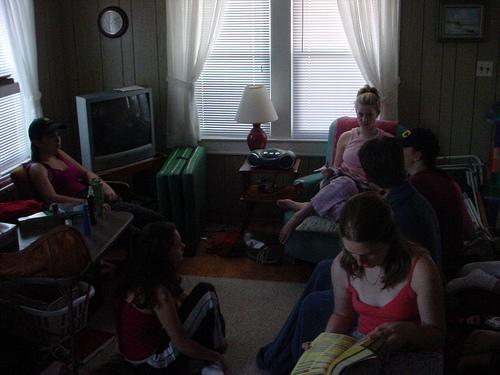What kind of pants is the girl in pink wearing?

Choices:
A) capris
B) leggings
C) pajama bottoms
D) jeans pajama bottoms 